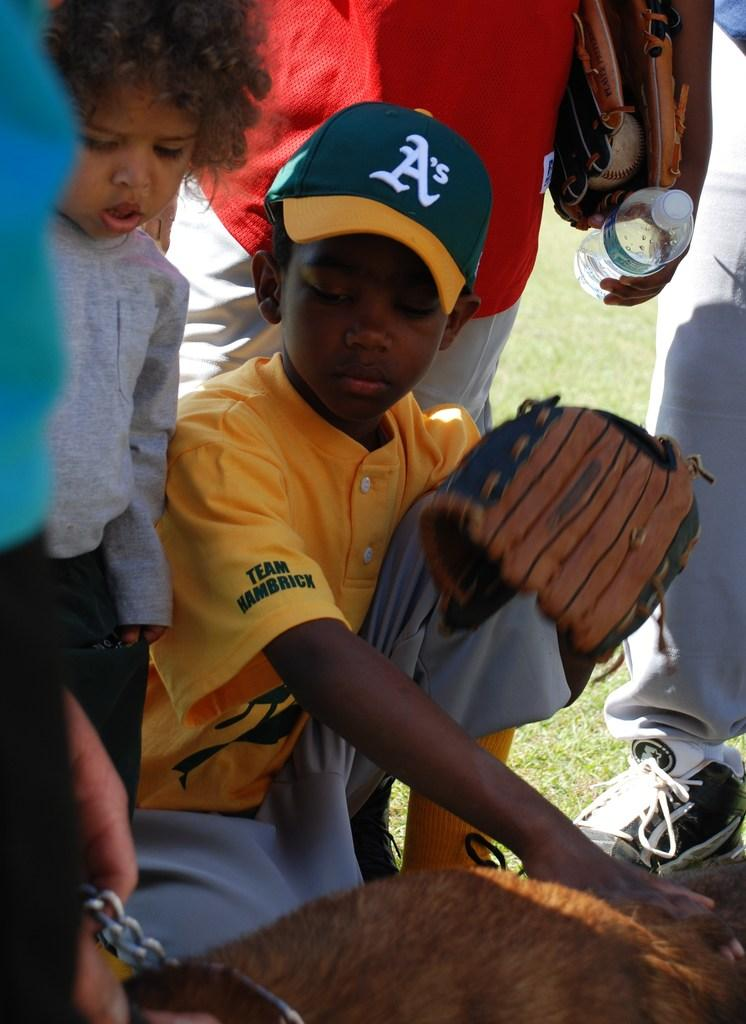<image>
Provide a brief description of the given image. A boy wears a hat with an A's logo. 